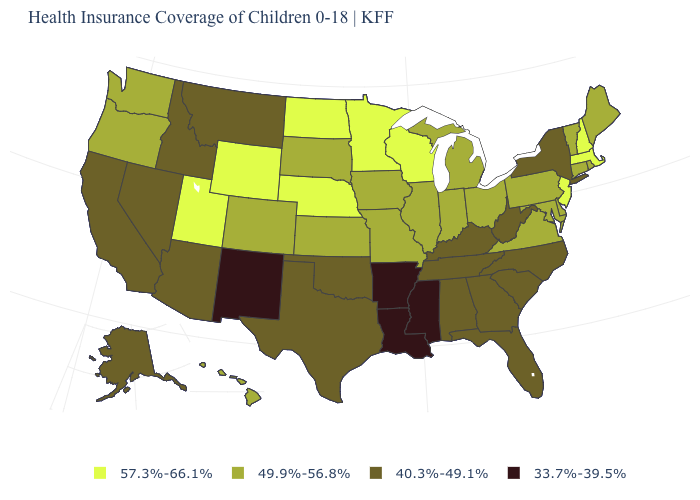What is the value of South Carolina?
Short answer required. 40.3%-49.1%. Name the states that have a value in the range 40.3%-49.1%?
Answer briefly. Alabama, Alaska, Arizona, California, Florida, Georgia, Idaho, Kentucky, Montana, Nevada, New York, North Carolina, Oklahoma, South Carolina, Tennessee, Texas, West Virginia. What is the value of New Mexico?
Answer briefly. 33.7%-39.5%. Name the states that have a value in the range 40.3%-49.1%?
Keep it brief. Alabama, Alaska, Arizona, California, Florida, Georgia, Idaho, Kentucky, Montana, Nevada, New York, North Carolina, Oklahoma, South Carolina, Tennessee, Texas, West Virginia. Which states hav the highest value in the West?
Answer briefly. Utah, Wyoming. What is the value of Massachusetts?
Keep it brief. 57.3%-66.1%. Name the states that have a value in the range 57.3%-66.1%?
Give a very brief answer. Massachusetts, Minnesota, Nebraska, New Hampshire, New Jersey, North Dakota, Utah, Wisconsin, Wyoming. What is the value of Tennessee?
Keep it brief. 40.3%-49.1%. Which states have the highest value in the USA?
Answer briefly. Massachusetts, Minnesota, Nebraska, New Hampshire, New Jersey, North Dakota, Utah, Wisconsin, Wyoming. Does the first symbol in the legend represent the smallest category?
Be succinct. No. Which states have the highest value in the USA?
Keep it brief. Massachusetts, Minnesota, Nebraska, New Hampshire, New Jersey, North Dakota, Utah, Wisconsin, Wyoming. What is the value of Florida?
Concise answer only. 40.3%-49.1%. Name the states that have a value in the range 40.3%-49.1%?
Short answer required. Alabama, Alaska, Arizona, California, Florida, Georgia, Idaho, Kentucky, Montana, Nevada, New York, North Carolina, Oklahoma, South Carolina, Tennessee, Texas, West Virginia. Does New Mexico have the lowest value in the USA?
Concise answer only. Yes. What is the lowest value in the MidWest?
Short answer required. 49.9%-56.8%. 